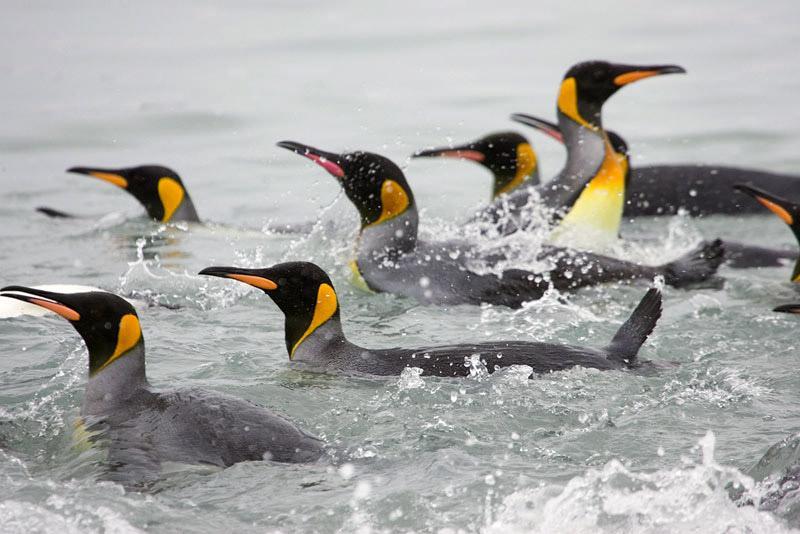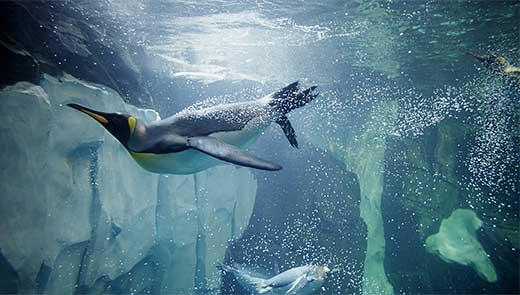The first image is the image on the left, the second image is the image on the right. Assess this claim about the two images: "There is no more than two penguins swimming underwater in the right image.". Correct or not? Answer yes or no. Yes. 